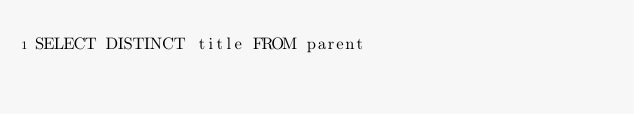Convert code to text. <code><loc_0><loc_0><loc_500><loc_500><_SQL_>SELECT DISTINCT title FROM parent
</code> 